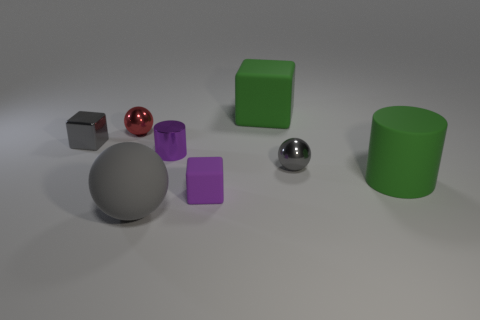Subtract all yellow cubes. How many gray balls are left? 2 Add 1 tiny purple metal things. How many objects exist? 9 Subtract all rubber blocks. How many blocks are left? 1 Subtract all cylinders. How many objects are left? 6 Add 5 large matte blocks. How many large matte blocks are left? 6 Add 4 big shiny blocks. How many big shiny blocks exist? 4 Subtract 0 red blocks. How many objects are left? 8 Subtract all gray matte spheres. Subtract all tiny cyan metallic things. How many objects are left? 7 